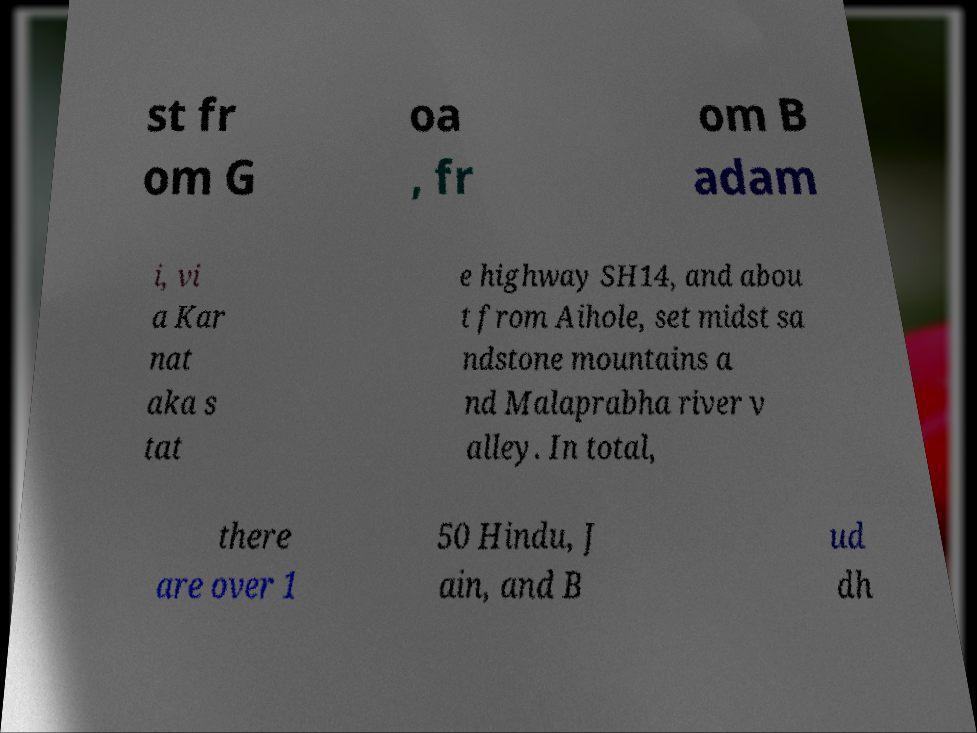There's text embedded in this image that I need extracted. Can you transcribe it verbatim? st fr om G oa , fr om B adam i, vi a Kar nat aka s tat e highway SH14, and abou t from Aihole, set midst sa ndstone mountains a nd Malaprabha river v alley. In total, there are over 1 50 Hindu, J ain, and B ud dh 